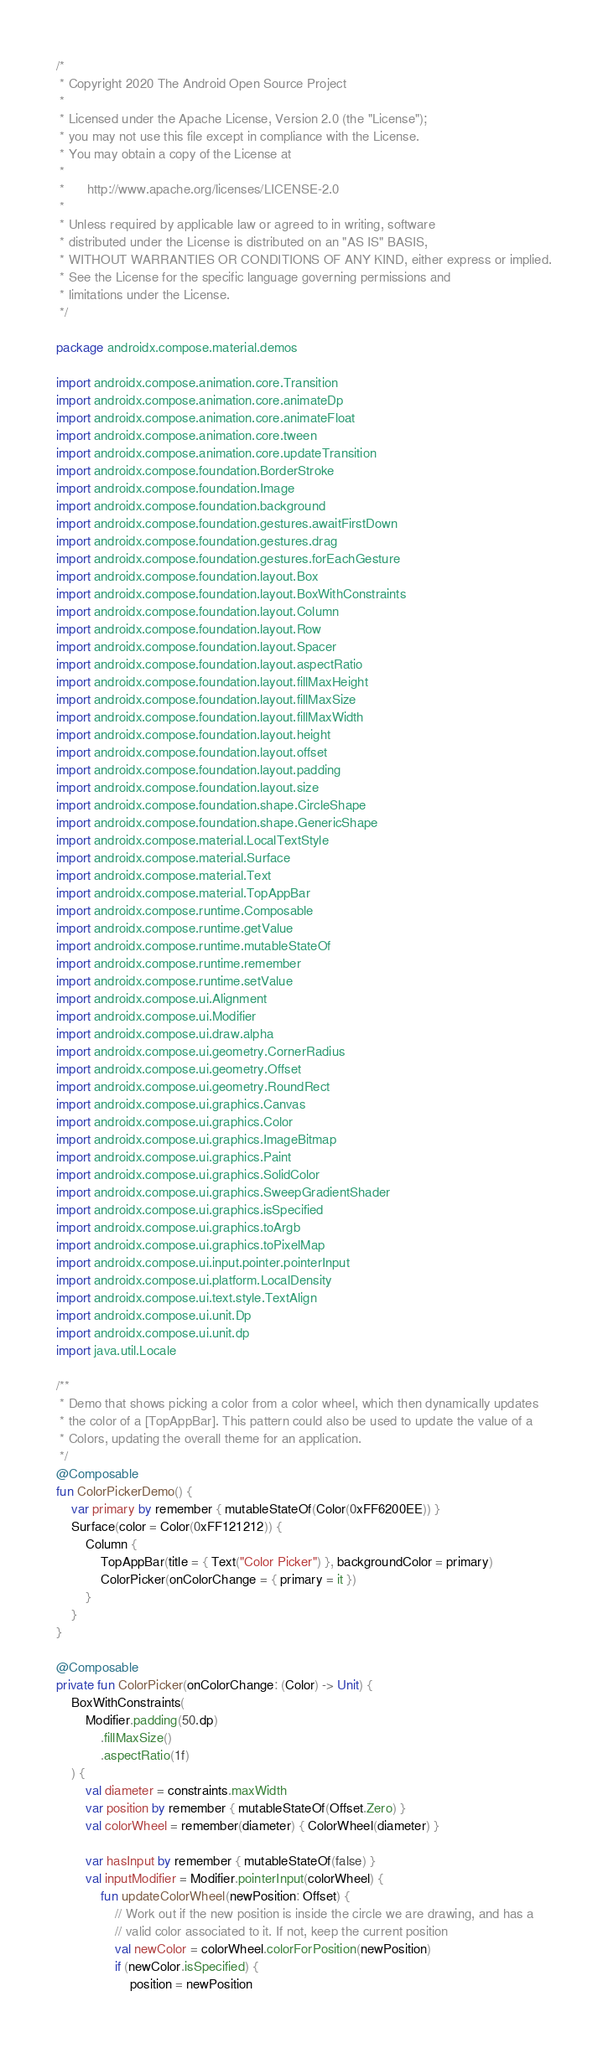<code> <loc_0><loc_0><loc_500><loc_500><_Kotlin_>/*
 * Copyright 2020 The Android Open Source Project
 *
 * Licensed under the Apache License, Version 2.0 (the "License");
 * you may not use this file except in compliance with the License.
 * You may obtain a copy of the License at
 *
 *      http://www.apache.org/licenses/LICENSE-2.0
 *
 * Unless required by applicable law or agreed to in writing, software
 * distributed under the License is distributed on an "AS IS" BASIS,
 * WITHOUT WARRANTIES OR CONDITIONS OF ANY KIND, either express or implied.
 * See the License for the specific language governing permissions and
 * limitations under the License.
 */

package androidx.compose.material.demos

import androidx.compose.animation.core.Transition
import androidx.compose.animation.core.animateDp
import androidx.compose.animation.core.animateFloat
import androidx.compose.animation.core.tween
import androidx.compose.animation.core.updateTransition
import androidx.compose.foundation.BorderStroke
import androidx.compose.foundation.Image
import androidx.compose.foundation.background
import androidx.compose.foundation.gestures.awaitFirstDown
import androidx.compose.foundation.gestures.drag
import androidx.compose.foundation.gestures.forEachGesture
import androidx.compose.foundation.layout.Box
import androidx.compose.foundation.layout.BoxWithConstraints
import androidx.compose.foundation.layout.Column
import androidx.compose.foundation.layout.Row
import androidx.compose.foundation.layout.Spacer
import androidx.compose.foundation.layout.aspectRatio
import androidx.compose.foundation.layout.fillMaxHeight
import androidx.compose.foundation.layout.fillMaxSize
import androidx.compose.foundation.layout.fillMaxWidth
import androidx.compose.foundation.layout.height
import androidx.compose.foundation.layout.offset
import androidx.compose.foundation.layout.padding
import androidx.compose.foundation.layout.size
import androidx.compose.foundation.shape.CircleShape
import androidx.compose.foundation.shape.GenericShape
import androidx.compose.material.LocalTextStyle
import androidx.compose.material.Surface
import androidx.compose.material.Text
import androidx.compose.material.TopAppBar
import androidx.compose.runtime.Composable
import androidx.compose.runtime.getValue
import androidx.compose.runtime.mutableStateOf
import androidx.compose.runtime.remember
import androidx.compose.runtime.setValue
import androidx.compose.ui.Alignment
import androidx.compose.ui.Modifier
import androidx.compose.ui.draw.alpha
import androidx.compose.ui.geometry.CornerRadius
import androidx.compose.ui.geometry.Offset
import androidx.compose.ui.geometry.RoundRect
import androidx.compose.ui.graphics.Canvas
import androidx.compose.ui.graphics.Color
import androidx.compose.ui.graphics.ImageBitmap
import androidx.compose.ui.graphics.Paint
import androidx.compose.ui.graphics.SolidColor
import androidx.compose.ui.graphics.SweepGradientShader
import androidx.compose.ui.graphics.isSpecified
import androidx.compose.ui.graphics.toArgb
import androidx.compose.ui.graphics.toPixelMap
import androidx.compose.ui.input.pointer.pointerInput
import androidx.compose.ui.platform.LocalDensity
import androidx.compose.ui.text.style.TextAlign
import androidx.compose.ui.unit.Dp
import androidx.compose.ui.unit.dp
import java.util.Locale

/**
 * Demo that shows picking a color from a color wheel, which then dynamically updates
 * the color of a [TopAppBar]. This pattern could also be used to update the value of a
 * Colors, updating the overall theme for an application.
 */
@Composable
fun ColorPickerDemo() {
    var primary by remember { mutableStateOf(Color(0xFF6200EE)) }
    Surface(color = Color(0xFF121212)) {
        Column {
            TopAppBar(title = { Text("Color Picker") }, backgroundColor = primary)
            ColorPicker(onColorChange = { primary = it })
        }
    }
}

@Composable
private fun ColorPicker(onColorChange: (Color) -> Unit) {
    BoxWithConstraints(
        Modifier.padding(50.dp)
            .fillMaxSize()
            .aspectRatio(1f)
    ) {
        val diameter = constraints.maxWidth
        var position by remember { mutableStateOf(Offset.Zero) }
        val colorWheel = remember(diameter) { ColorWheel(diameter) }

        var hasInput by remember { mutableStateOf(false) }
        val inputModifier = Modifier.pointerInput(colorWheel) {
            fun updateColorWheel(newPosition: Offset) {
                // Work out if the new position is inside the circle we are drawing, and has a
                // valid color associated to it. If not, keep the current position
                val newColor = colorWheel.colorForPosition(newPosition)
                if (newColor.isSpecified) {
                    position = newPosition</code> 